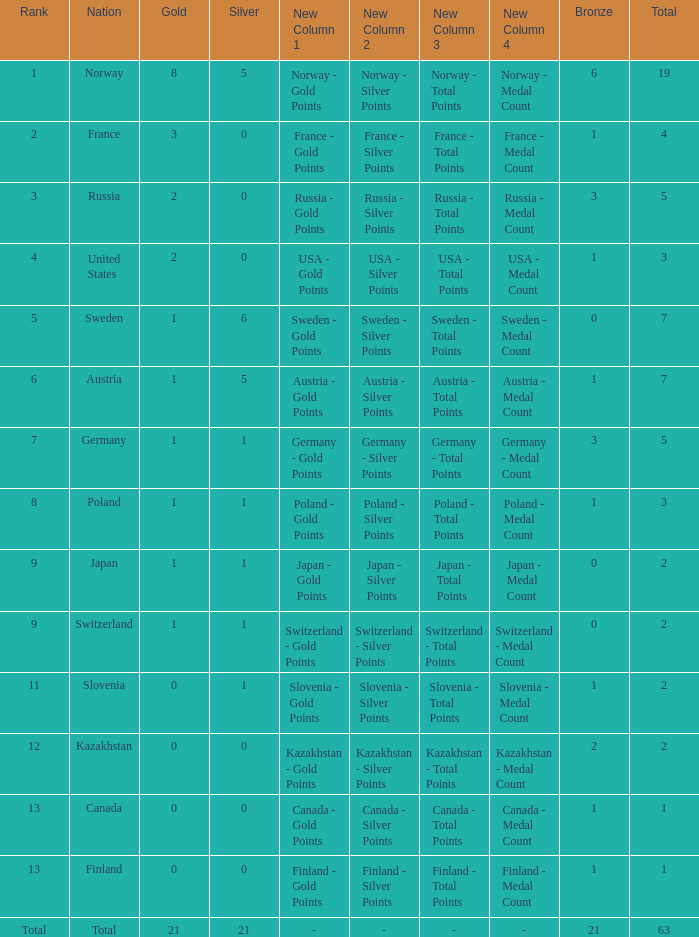What Rank has a gold smaller than 1, and a silver larger than 0? 11.0. 